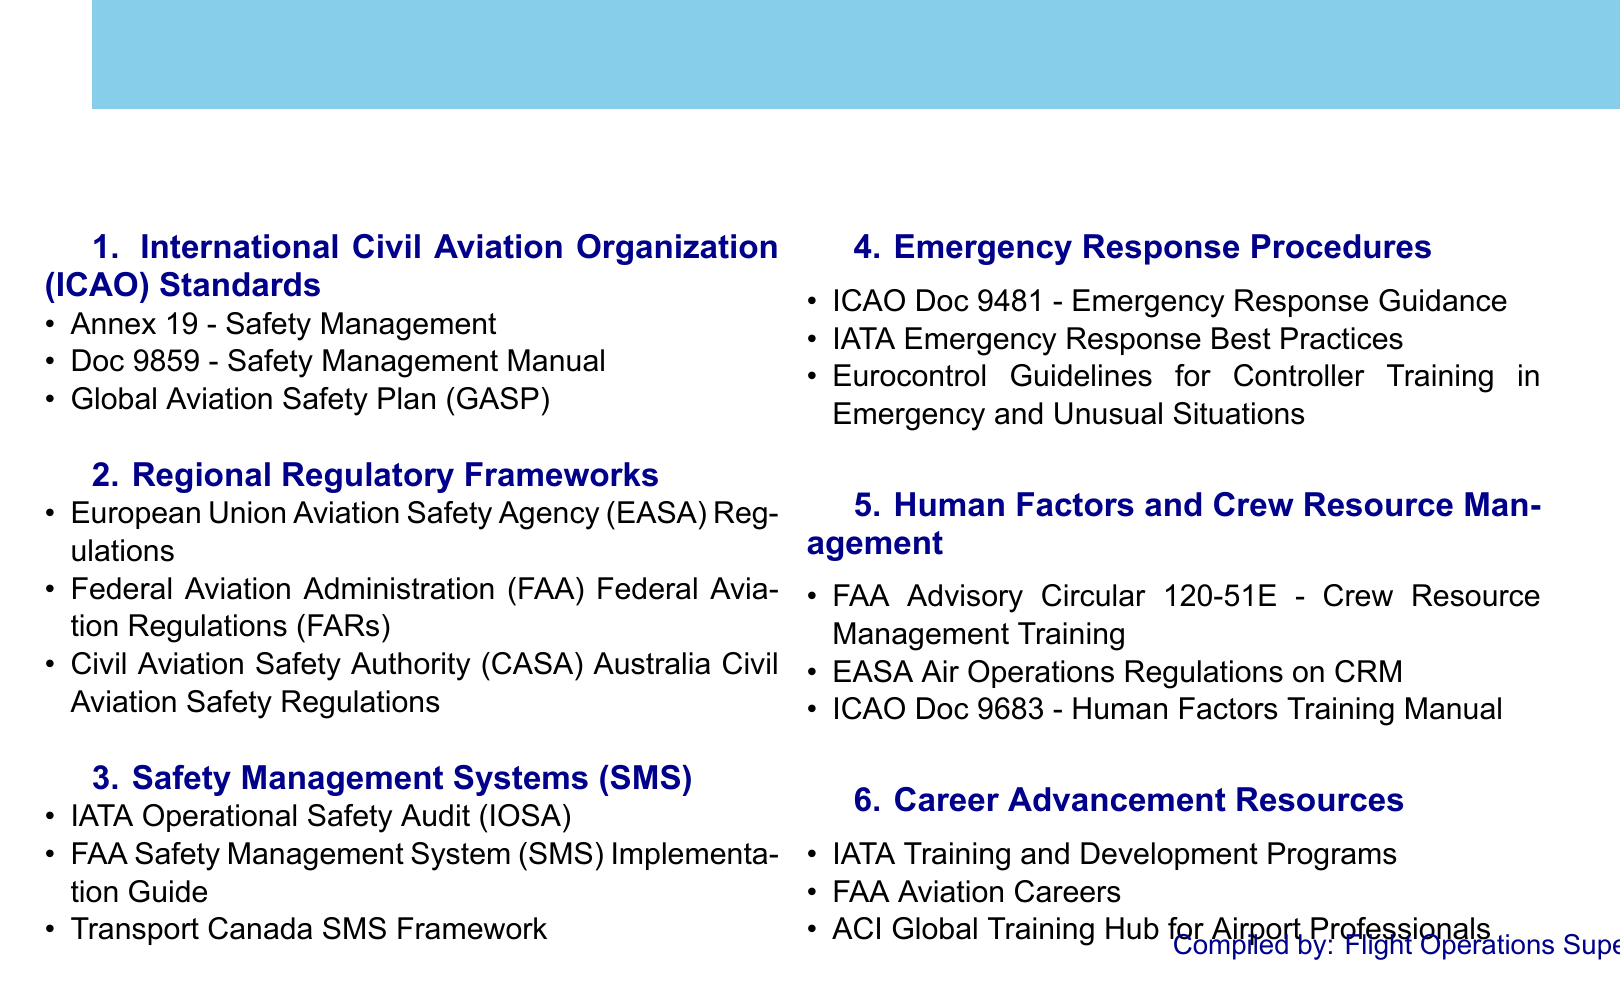What is Annex 19? Annex 19 is part of the ICAO Standards subsection in the document, which focuses on Safety Management.
Answer: Safety Management Which organization provides the Emergency Response Guidance? ICAO Doc 9481 provides Emergency Response Guidance as stated in the document.
Answer: ICAO What document includes the Safety Management Manual? The document mentions Doc 9859, which is the Safety Management Manual.
Answer: Doc 9859 What training program is mentioned for enhancing Crew Resource Management? The FAA Advisory Circular 120-51E discusses Crew Resource Management Training.
Answer: FAA Advisory Circular 120-51E How many sections are listed in the document? The document lists six sections under Global Aviation Safety Regulations and Best Practices.
Answer: Six Which regulatory framework does not belong to the European Union? The FAA Federal Aviation Regulations (FARs) is the only regulatory framework that does not belong to the European Union.
Answer: FAA Federal Aviation Regulations What organization conducts the Operational Safety Audit? The document mentions IATA for conducting the Operational Safety Audit.
Answer: IATA What is the primary purpose of the Global Aviation Safety Plan? The Global Aviation Safety Plan (GASP) serves as a framework for safety management in aviation.
Answer: Framework for safety management 